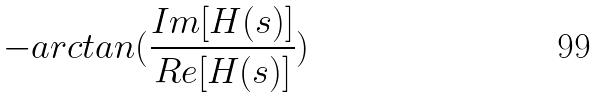<formula> <loc_0><loc_0><loc_500><loc_500>- a r c t a n ( \frac { I m [ H ( s ) ] } { R e [ H ( s ) ] } )</formula> 